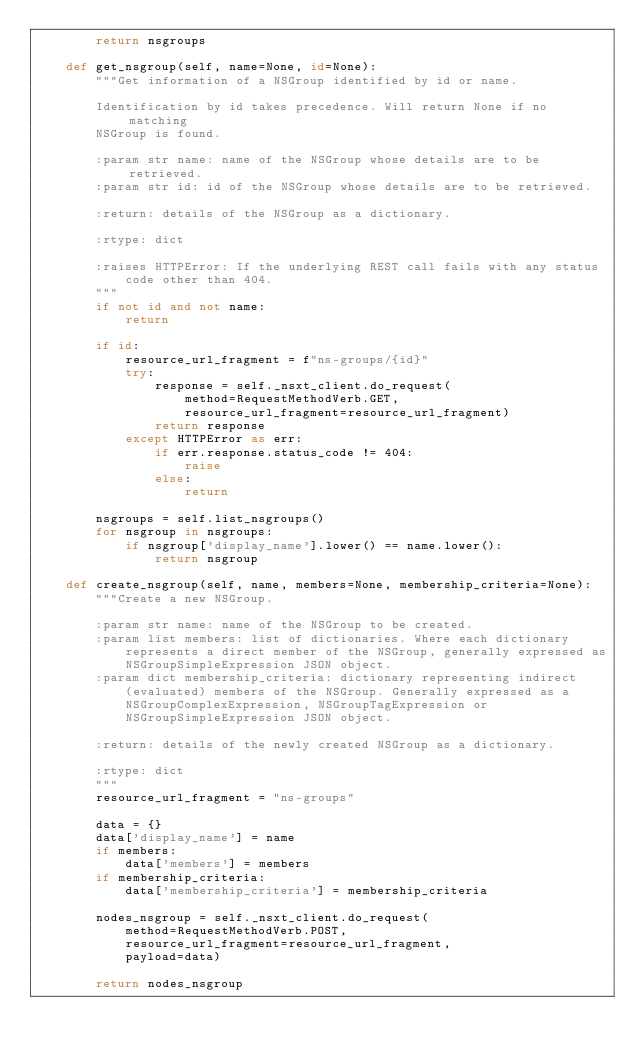Convert code to text. <code><loc_0><loc_0><loc_500><loc_500><_Python_>        return nsgroups

    def get_nsgroup(self, name=None, id=None):
        """Get information of a NSGroup identified by id or name.

        Identification by id takes precedence. Will return None if no matching
        NSGroup is found.

        :param str name: name of the NSGroup whose details are to be retrieved.
        :param str id: id of the NSGroup whose details are to be retrieved.

        :return: details of the NSGroup as a dictionary.

        :rtype: dict

        :raises HTTPError: If the underlying REST call fails with any status
            code other than 404.
        """
        if not id and not name:
            return

        if id:
            resource_url_fragment = f"ns-groups/{id}"
            try:
                response = self._nsxt_client.do_request(
                    method=RequestMethodVerb.GET,
                    resource_url_fragment=resource_url_fragment)
                return response
            except HTTPError as err:
                if err.response.status_code != 404:
                    raise
                else:
                    return

        nsgroups = self.list_nsgroups()
        for nsgroup in nsgroups:
            if nsgroup['display_name'].lower() == name.lower():
                return nsgroup

    def create_nsgroup(self, name, members=None, membership_criteria=None):
        """Create a new NSGroup.

        :param str name: name of the NSGroup to be created.
        :param list members: list of dictionaries. Where each dictionary
            represents a direct member of the NSGroup, generally expressed as
            NSGroupSimpleExpression JSON object.
        :param dict membership_criteria: dictionary representing indirect
            (evaluated) members of the NSGroup. Generally expressed as a
            NSGroupComplexExpression, NSGroupTagExpression or
            NSGroupSimpleExpression JSON object.

        :return: details of the newly created NSGroup as a dictionary.

        :rtype: dict
        """
        resource_url_fragment = "ns-groups"

        data = {}
        data['display_name'] = name
        if members:
            data['members'] = members
        if membership_criteria:
            data['membership_criteria'] = membership_criteria

        nodes_nsgroup = self._nsxt_client.do_request(
            method=RequestMethodVerb.POST,
            resource_url_fragment=resource_url_fragment,
            payload=data)

        return nodes_nsgroup
</code> 